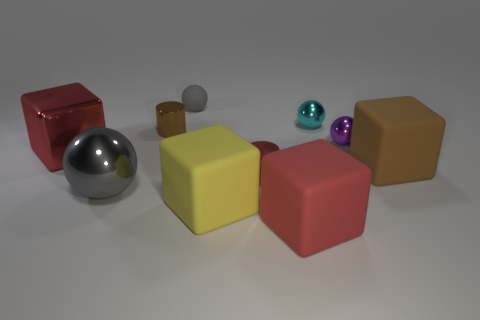Subtract 1 cubes. How many cubes are left? 3 Subtract all cubes. How many objects are left? 6 Add 9 big brown things. How many big brown things are left? 10 Add 3 large metal spheres. How many large metal spheres exist? 4 Subtract 0 cyan cubes. How many objects are left? 10 Subtract all large red balls. Subtract all large objects. How many objects are left? 5 